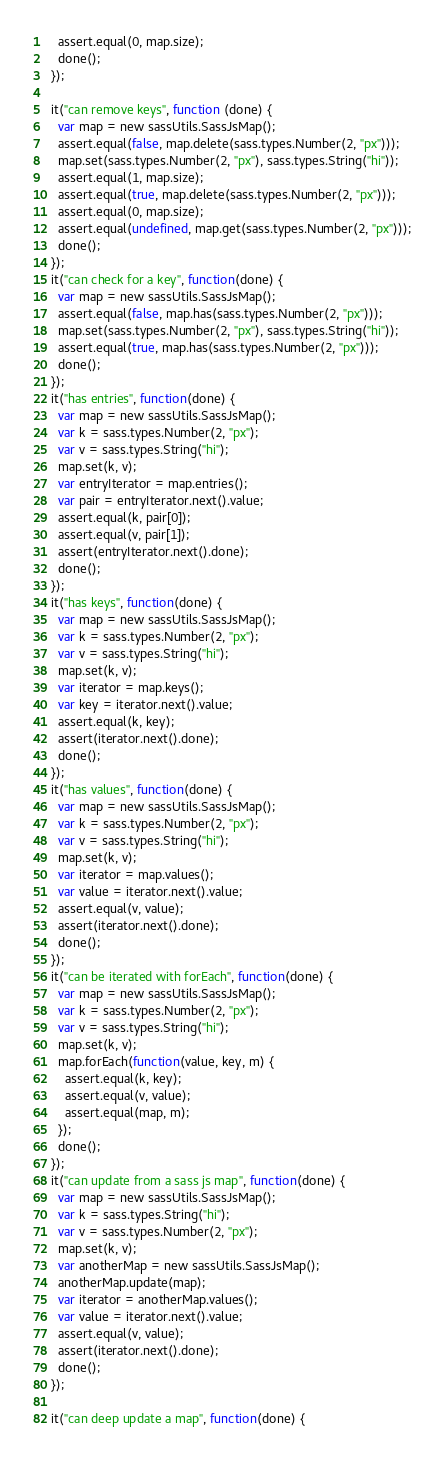Convert code to text. <code><loc_0><loc_0><loc_500><loc_500><_JavaScript_>    assert.equal(0, map.size);
    done();
  });

  it("can remove keys", function (done) {
    var map = new sassUtils.SassJsMap();
    assert.equal(false, map.delete(sass.types.Number(2, "px")));
    map.set(sass.types.Number(2, "px"), sass.types.String("hi"));
    assert.equal(1, map.size);
    assert.equal(true, map.delete(sass.types.Number(2, "px")));
    assert.equal(0, map.size);
    assert.equal(undefined, map.get(sass.types.Number(2, "px")));
    done();
  });
  it("can check for a key", function(done) {
    var map = new sassUtils.SassJsMap();
    assert.equal(false, map.has(sass.types.Number(2, "px")));
    map.set(sass.types.Number(2, "px"), sass.types.String("hi"));
    assert.equal(true, map.has(sass.types.Number(2, "px")));
    done();
  });
  it("has entries", function(done) {
    var map = new sassUtils.SassJsMap();
    var k = sass.types.Number(2, "px");
    var v = sass.types.String("hi");
    map.set(k, v);
    var entryIterator = map.entries();
    var pair = entryIterator.next().value;
    assert.equal(k, pair[0]);
    assert.equal(v, pair[1]);
    assert(entryIterator.next().done);
    done();
  });
  it("has keys", function(done) {
    var map = new sassUtils.SassJsMap();
    var k = sass.types.Number(2, "px");
    var v = sass.types.String("hi");
    map.set(k, v);
    var iterator = map.keys();
    var key = iterator.next().value;
    assert.equal(k, key);
    assert(iterator.next().done);
    done();
  });
  it("has values", function(done) {
    var map = new sassUtils.SassJsMap();
    var k = sass.types.Number(2, "px");
    var v = sass.types.String("hi");
    map.set(k, v);
    var iterator = map.values();
    var value = iterator.next().value;
    assert.equal(v, value);
    assert(iterator.next().done);
    done();
  });
  it("can be iterated with forEach", function(done) {
    var map = new sassUtils.SassJsMap();
    var k = sass.types.Number(2, "px");
    var v = sass.types.String("hi");
    map.set(k, v);
    map.forEach(function(value, key, m) {
      assert.equal(k, key);
      assert.equal(v, value);
      assert.equal(map, m);
    });
    done();
  });
  it("can update from a sass js map", function(done) {
    var map = new sassUtils.SassJsMap();
    var k = sass.types.String("hi");
    var v = sass.types.Number(2, "px");
    map.set(k, v);
    var anotherMap = new sassUtils.SassJsMap();
    anotherMap.update(map);
    var iterator = anotherMap.values();
    var value = iterator.next().value;
    assert.equal(v, value);
    assert(iterator.next().done);
    done();
  });

  it("can deep update a map", function(done) {</code> 